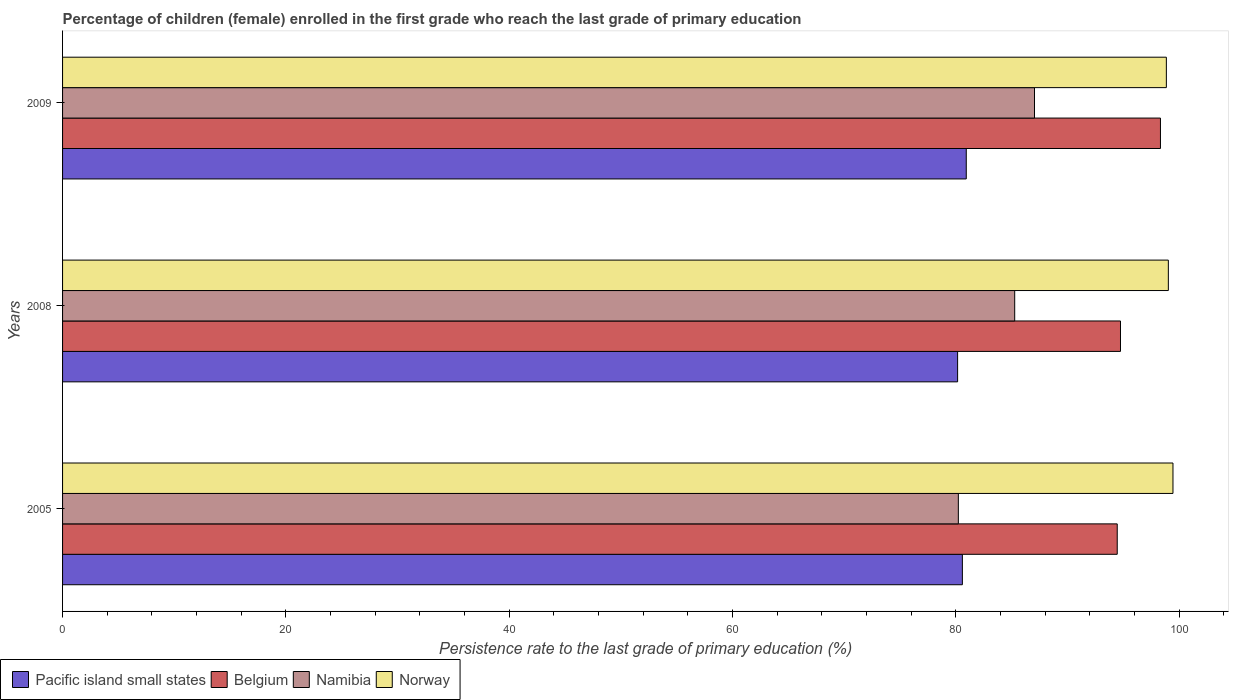How many different coloured bars are there?
Ensure brevity in your answer.  4. How many bars are there on the 3rd tick from the top?
Your answer should be compact. 4. What is the persistence rate of children in Pacific island small states in 2008?
Your answer should be compact. 80.16. Across all years, what is the maximum persistence rate of children in Belgium?
Provide a short and direct response. 98.32. Across all years, what is the minimum persistence rate of children in Belgium?
Provide a succinct answer. 94.45. In which year was the persistence rate of children in Belgium maximum?
Offer a terse response. 2009. In which year was the persistence rate of children in Norway minimum?
Provide a succinct answer. 2009. What is the total persistence rate of children in Namibia in the graph?
Provide a short and direct response. 252.54. What is the difference between the persistence rate of children in Namibia in 2005 and that in 2009?
Offer a terse response. -6.82. What is the difference between the persistence rate of children in Namibia in 2005 and the persistence rate of children in Pacific island small states in 2008?
Provide a short and direct response. 0.07. What is the average persistence rate of children in Namibia per year?
Offer a terse response. 84.18. In the year 2005, what is the difference between the persistence rate of children in Belgium and persistence rate of children in Norway?
Make the answer very short. -4.99. What is the ratio of the persistence rate of children in Namibia in 2005 to that in 2008?
Offer a very short reply. 0.94. Is the difference between the persistence rate of children in Belgium in 2005 and 2009 greater than the difference between the persistence rate of children in Norway in 2005 and 2009?
Give a very brief answer. No. What is the difference between the highest and the second highest persistence rate of children in Namibia?
Your answer should be compact. 1.77. What is the difference between the highest and the lowest persistence rate of children in Norway?
Make the answer very short. 0.59. What does the 4th bar from the top in 2005 represents?
Ensure brevity in your answer.  Pacific island small states. Are all the bars in the graph horizontal?
Give a very brief answer. Yes. Are the values on the major ticks of X-axis written in scientific E-notation?
Your response must be concise. No. Does the graph contain grids?
Offer a terse response. No. Where does the legend appear in the graph?
Offer a very short reply. Bottom left. How many legend labels are there?
Keep it short and to the point. 4. How are the legend labels stacked?
Give a very brief answer. Horizontal. What is the title of the graph?
Your response must be concise. Percentage of children (female) enrolled in the first grade who reach the last grade of primary education. Does "Mali" appear as one of the legend labels in the graph?
Offer a very short reply. No. What is the label or title of the X-axis?
Your response must be concise. Persistence rate to the last grade of primary education (%). What is the Persistence rate to the last grade of primary education (%) in Pacific island small states in 2005?
Provide a succinct answer. 80.58. What is the Persistence rate to the last grade of primary education (%) in Belgium in 2005?
Ensure brevity in your answer.  94.45. What is the Persistence rate to the last grade of primary education (%) of Namibia in 2005?
Make the answer very short. 80.22. What is the Persistence rate to the last grade of primary education (%) in Norway in 2005?
Give a very brief answer. 99.45. What is the Persistence rate to the last grade of primary education (%) in Pacific island small states in 2008?
Make the answer very short. 80.16. What is the Persistence rate to the last grade of primary education (%) in Belgium in 2008?
Provide a short and direct response. 94.75. What is the Persistence rate to the last grade of primary education (%) of Namibia in 2008?
Give a very brief answer. 85.27. What is the Persistence rate to the last grade of primary education (%) in Norway in 2008?
Offer a very short reply. 99.03. What is the Persistence rate to the last grade of primary education (%) in Pacific island small states in 2009?
Ensure brevity in your answer.  80.93. What is the Persistence rate to the last grade of primary education (%) in Belgium in 2009?
Your answer should be very brief. 98.32. What is the Persistence rate to the last grade of primary education (%) in Namibia in 2009?
Your answer should be compact. 87.05. What is the Persistence rate to the last grade of primary education (%) in Norway in 2009?
Provide a short and direct response. 98.85. Across all years, what is the maximum Persistence rate to the last grade of primary education (%) in Pacific island small states?
Offer a terse response. 80.93. Across all years, what is the maximum Persistence rate to the last grade of primary education (%) of Belgium?
Give a very brief answer. 98.32. Across all years, what is the maximum Persistence rate to the last grade of primary education (%) of Namibia?
Your response must be concise. 87.05. Across all years, what is the maximum Persistence rate to the last grade of primary education (%) in Norway?
Make the answer very short. 99.45. Across all years, what is the minimum Persistence rate to the last grade of primary education (%) in Pacific island small states?
Keep it short and to the point. 80.16. Across all years, what is the minimum Persistence rate to the last grade of primary education (%) of Belgium?
Ensure brevity in your answer.  94.45. Across all years, what is the minimum Persistence rate to the last grade of primary education (%) in Namibia?
Offer a very short reply. 80.22. Across all years, what is the minimum Persistence rate to the last grade of primary education (%) in Norway?
Give a very brief answer. 98.85. What is the total Persistence rate to the last grade of primary education (%) of Pacific island small states in the graph?
Offer a terse response. 241.68. What is the total Persistence rate to the last grade of primary education (%) of Belgium in the graph?
Give a very brief answer. 287.52. What is the total Persistence rate to the last grade of primary education (%) of Namibia in the graph?
Ensure brevity in your answer.  252.54. What is the total Persistence rate to the last grade of primary education (%) in Norway in the graph?
Provide a succinct answer. 297.33. What is the difference between the Persistence rate to the last grade of primary education (%) of Pacific island small states in 2005 and that in 2008?
Provide a short and direct response. 0.43. What is the difference between the Persistence rate to the last grade of primary education (%) of Belgium in 2005 and that in 2008?
Make the answer very short. -0.29. What is the difference between the Persistence rate to the last grade of primary education (%) in Namibia in 2005 and that in 2008?
Your response must be concise. -5.05. What is the difference between the Persistence rate to the last grade of primary education (%) of Norway in 2005 and that in 2008?
Offer a very short reply. 0.41. What is the difference between the Persistence rate to the last grade of primary education (%) in Pacific island small states in 2005 and that in 2009?
Offer a very short reply. -0.35. What is the difference between the Persistence rate to the last grade of primary education (%) in Belgium in 2005 and that in 2009?
Offer a terse response. -3.87. What is the difference between the Persistence rate to the last grade of primary education (%) of Namibia in 2005 and that in 2009?
Offer a very short reply. -6.82. What is the difference between the Persistence rate to the last grade of primary education (%) of Norway in 2005 and that in 2009?
Offer a very short reply. 0.59. What is the difference between the Persistence rate to the last grade of primary education (%) of Pacific island small states in 2008 and that in 2009?
Keep it short and to the point. -0.77. What is the difference between the Persistence rate to the last grade of primary education (%) of Belgium in 2008 and that in 2009?
Provide a succinct answer. -3.58. What is the difference between the Persistence rate to the last grade of primary education (%) of Namibia in 2008 and that in 2009?
Your answer should be compact. -1.77. What is the difference between the Persistence rate to the last grade of primary education (%) of Norway in 2008 and that in 2009?
Your answer should be compact. 0.18. What is the difference between the Persistence rate to the last grade of primary education (%) of Pacific island small states in 2005 and the Persistence rate to the last grade of primary education (%) of Belgium in 2008?
Give a very brief answer. -14.16. What is the difference between the Persistence rate to the last grade of primary education (%) in Pacific island small states in 2005 and the Persistence rate to the last grade of primary education (%) in Namibia in 2008?
Give a very brief answer. -4.69. What is the difference between the Persistence rate to the last grade of primary education (%) of Pacific island small states in 2005 and the Persistence rate to the last grade of primary education (%) of Norway in 2008?
Make the answer very short. -18.45. What is the difference between the Persistence rate to the last grade of primary education (%) in Belgium in 2005 and the Persistence rate to the last grade of primary education (%) in Namibia in 2008?
Make the answer very short. 9.18. What is the difference between the Persistence rate to the last grade of primary education (%) of Belgium in 2005 and the Persistence rate to the last grade of primary education (%) of Norway in 2008?
Offer a very short reply. -4.58. What is the difference between the Persistence rate to the last grade of primary education (%) of Namibia in 2005 and the Persistence rate to the last grade of primary education (%) of Norway in 2008?
Make the answer very short. -18.81. What is the difference between the Persistence rate to the last grade of primary education (%) of Pacific island small states in 2005 and the Persistence rate to the last grade of primary education (%) of Belgium in 2009?
Your response must be concise. -17.74. What is the difference between the Persistence rate to the last grade of primary education (%) of Pacific island small states in 2005 and the Persistence rate to the last grade of primary education (%) of Namibia in 2009?
Make the answer very short. -6.46. What is the difference between the Persistence rate to the last grade of primary education (%) in Pacific island small states in 2005 and the Persistence rate to the last grade of primary education (%) in Norway in 2009?
Your answer should be compact. -18.27. What is the difference between the Persistence rate to the last grade of primary education (%) of Belgium in 2005 and the Persistence rate to the last grade of primary education (%) of Namibia in 2009?
Provide a short and direct response. 7.41. What is the difference between the Persistence rate to the last grade of primary education (%) of Belgium in 2005 and the Persistence rate to the last grade of primary education (%) of Norway in 2009?
Ensure brevity in your answer.  -4.4. What is the difference between the Persistence rate to the last grade of primary education (%) in Namibia in 2005 and the Persistence rate to the last grade of primary education (%) in Norway in 2009?
Make the answer very short. -18.63. What is the difference between the Persistence rate to the last grade of primary education (%) of Pacific island small states in 2008 and the Persistence rate to the last grade of primary education (%) of Belgium in 2009?
Make the answer very short. -18.17. What is the difference between the Persistence rate to the last grade of primary education (%) of Pacific island small states in 2008 and the Persistence rate to the last grade of primary education (%) of Namibia in 2009?
Offer a very short reply. -6.89. What is the difference between the Persistence rate to the last grade of primary education (%) in Pacific island small states in 2008 and the Persistence rate to the last grade of primary education (%) in Norway in 2009?
Offer a very short reply. -18.7. What is the difference between the Persistence rate to the last grade of primary education (%) of Belgium in 2008 and the Persistence rate to the last grade of primary education (%) of Namibia in 2009?
Give a very brief answer. 7.7. What is the difference between the Persistence rate to the last grade of primary education (%) in Belgium in 2008 and the Persistence rate to the last grade of primary education (%) in Norway in 2009?
Provide a short and direct response. -4.11. What is the difference between the Persistence rate to the last grade of primary education (%) of Namibia in 2008 and the Persistence rate to the last grade of primary education (%) of Norway in 2009?
Offer a very short reply. -13.58. What is the average Persistence rate to the last grade of primary education (%) in Pacific island small states per year?
Give a very brief answer. 80.56. What is the average Persistence rate to the last grade of primary education (%) in Belgium per year?
Offer a very short reply. 95.84. What is the average Persistence rate to the last grade of primary education (%) of Namibia per year?
Provide a succinct answer. 84.18. What is the average Persistence rate to the last grade of primary education (%) of Norway per year?
Your answer should be compact. 99.11. In the year 2005, what is the difference between the Persistence rate to the last grade of primary education (%) of Pacific island small states and Persistence rate to the last grade of primary education (%) of Belgium?
Keep it short and to the point. -13.87. In the year 2005, what is the difference between the Persistence rate to the last grade of primary education (%) of Pacific island small states and Persistence rate to the last grade of primary education (%) of Namibia?
Give a very brief answer. 0.36. In the year 2005, what is the difference between the Persistence rate to the last grade of primary education (%) of Pacific island small states and Persistence rate to the last grade of primary education (%) of Norway?
Ensure brevity in your answer.  -18.86. In the year 2005, what is the difference between the Persistence rate to the last grade of primary education (%) in Belgium and Persistence rate to the last grade of primary education (%) in Namibia?
Provide a succinct answer. 14.23. In the year 2005, what is the difference between the Persistence rate to the last grade of primary education (%) in Belgium and Persistence rate to the last grade of primary education (%) in Norway?
Provide a succinct answer. -4.99. In the year 2005, what is the difference between the Persistence rate to the last grade of primary education (%) of Namibia and Persistence rate to the last grade of primary education (%) of Norway?
Keep it short and to the point. -19.22. In the year 2008, what is the difference between the Persistence rate to the last grade of primary education (%) of Pacific island small states and Persistence rate to the last grade of primary education (%) of Belgium?
Provide a short and direct response. -14.59. In the year 2008, what is the difference between the Persistence rate to the last grade of primary education (%) of Pacific island small states and Persistence rate to the last grade of primary education (%) of Namibia?
Offer a terse response. -5.11. In the year 2008, what is the difference between the Persistence rate to the last grade of primary education (%) in Pacific island small states and Persistence rate to the last grade of primary education (%) in Norway?
Provide a succinct answer. -18.87. In the year 2008, what is the difference between the Persistence rate to the last grade of primary education (%) of Belgium and Persistence rate to the last grade of primary education (%) of Namibia?
Provide a short and direct response. 9.47. In the year 2008, what is the difference between the Persistence rate to the last grade of primary education (%) in Belgium and Persistence rate to the last grade of primary education (%) in Norway?
Offer a very short reply. -4.29. In the year 2008, what is the difference between the Persistence rate to the last grade of primary education (%) of Namibia and Persistence rate to the last grade of primary education (%) of Norway?
Your answer should be very brief. -13.76. In the year 2009, what is the difference between the Persistence rate to the last grade of primary education (%) of Pacific island small states and Persistence rate to the last grade of primary education (%) of Belgium?
Make the answer very short. -17.39. In the year 2009, what is the difference between the Persistence rate to the last grade of primary education (%) of Pacific island small states and Persistence rate to the last grade of primary education (%) of Namibia?
Your answer should be very brief. -6.11. In the year 2009, what is the difference between the Persistence rate to the last grade of primary education (%) in Pacific island small states and Persistence rate to the last grade of primary education (%) in Norway?
Your answer should be very brief. -17.92. In the year 2009, what is the difference between the Persistence rate to the last grade of primary education (%) in Belgium and Persistence rate to the last grade of primary education (%) in Namibia?
Provide a succinct answer. 11.28. In the year 2009, what is the difference between the Persistence rate to the last grade of primary education (%) in Belgium and Persistence rate to the last grade of primary education (%) in Norway?
Give a very brief answer. -0.53. In the year 2009, what is the difference between the Persistence rate to the last grade of primary education (%) in Namibia and Persistence rate to the last grade of primary education (%) in Norway?
Give a very brief answer. -11.81. What is the ratio of the Persistence rate to the last grade of primary education (%) in Belgium in 2005 to that in 2008?
Your answer should be compact. 1. What is the ratio of the Persistence rate to the last grade of primary education (%) of Namibia in 2005 to that in 2008?
Your response must be concise. 0.94. What is the ratio of the Persistence rate to the last grade of primary education (%) in Belgium in 2005 to that in 2009?
Make the answer very short. 0.96. What is the ratio of the Persistence rate to the last grade of primary education (%) of Namibia in 2005 to that in 2009?
Provide a short and direct response. 0.92. What is the ratio of the Persistence rate to the last grade of primary education (%) of Pacific island small states in 2008 to that in 2009?
Your response must be concise. 0.99. What is the ratio of the Persistence rate to the last grade of primary education (%) of Belgium in 2008 to that in 2009?
Your answer should be very brief. 0.96. What is the ratio of the Persistence rate to the last grade of primary education (%) of Namibia in 2008 to that in 2009?
Offer a very short reply. 0.98. What is the ratio of the Persistence rate to the last grade of primary education (%) in Norway in 2008 to that in 2009?
Provide a short and direct response. 1. What is the difference between the highest and the second highest Persistence rate to the last grade of primary education (%) in Pacific island small states?
Provide a succinct answer. 0.35. What is the difference between the highest and the second highest Persistence rate to the last grade of primary education (%) in Belgium?
Offer a terse response. 3.58. What is the difference between the highest and the second highest Persistence rate to the last grade of primary education (%) of Namibia?
Provide a succinct answer. 1.77. What is the difference between the highest and the second highest Persistence rate to the last grade of primary education (%) of Norway?
Provide a succinct answer. 0.41. What is the difference between the highest and the lowest Persistence rate to the last grade of primary education (%) of Pacific island small states?
Offer a terse response. 0.77. What is the difference between the highest and the lowest Persistence rate to the last grade of primary education (%) of Belgium?
Provide a succinct answer. 3.87. What is the difference between the highest and the lowest Persistence rate to the last grade of primary education (%) in Namibia?
Your response must be concise. 6.82. What is the difference between the highest and the lowest Persistence rate to the last grade of primary education (%) of Norway?
Offer a very short reply. 0.59. 